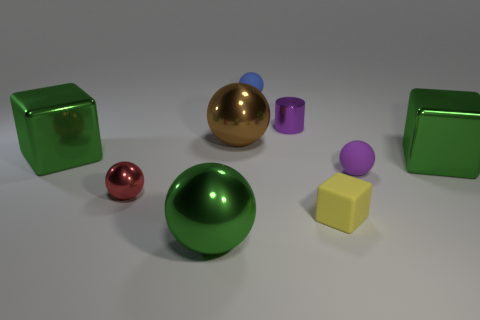There is a small object that is the same color as the cylinder; what material is it?
Offer a very short reply. Rubber. What number of green metal things have the same shape as the tiny red shiny object?
Your response must be concise. 1. There is a rubber ball that is in front of the green cube that is in front of the green metal cube that is left of the cylinder; what size is it?
Make the answer very short. Small. There is a matte ball on the left side of the small block; is its color the same as the large metallic block that is on the right side of the small blue rubber thing?
Your response must be concise. No. How many yellow things are small metal cylinders or blocks?
Provide a succinct answer. 1. How many green spheres have the same size as the brown object?
Offer a very short reply. 1. Do the green cube that is to the left of the tiny red shiny sphere and the tiny blue ball have the same material?
Provide a succinct answer. No. There is a tiny rubber ball left of the purple metal thing; are there any big green shiny blocks behind it?
Provide a succinct answer. No. There is a red object that is the same shape as the small purple rubber object; what is it made of?
Your answer should be compact. Metal. Are there more red metallic things that are on the left side of the tiny metal sphere than tiny blue balls in front of the large brown metal ball?
Your answer should be compact. No. 